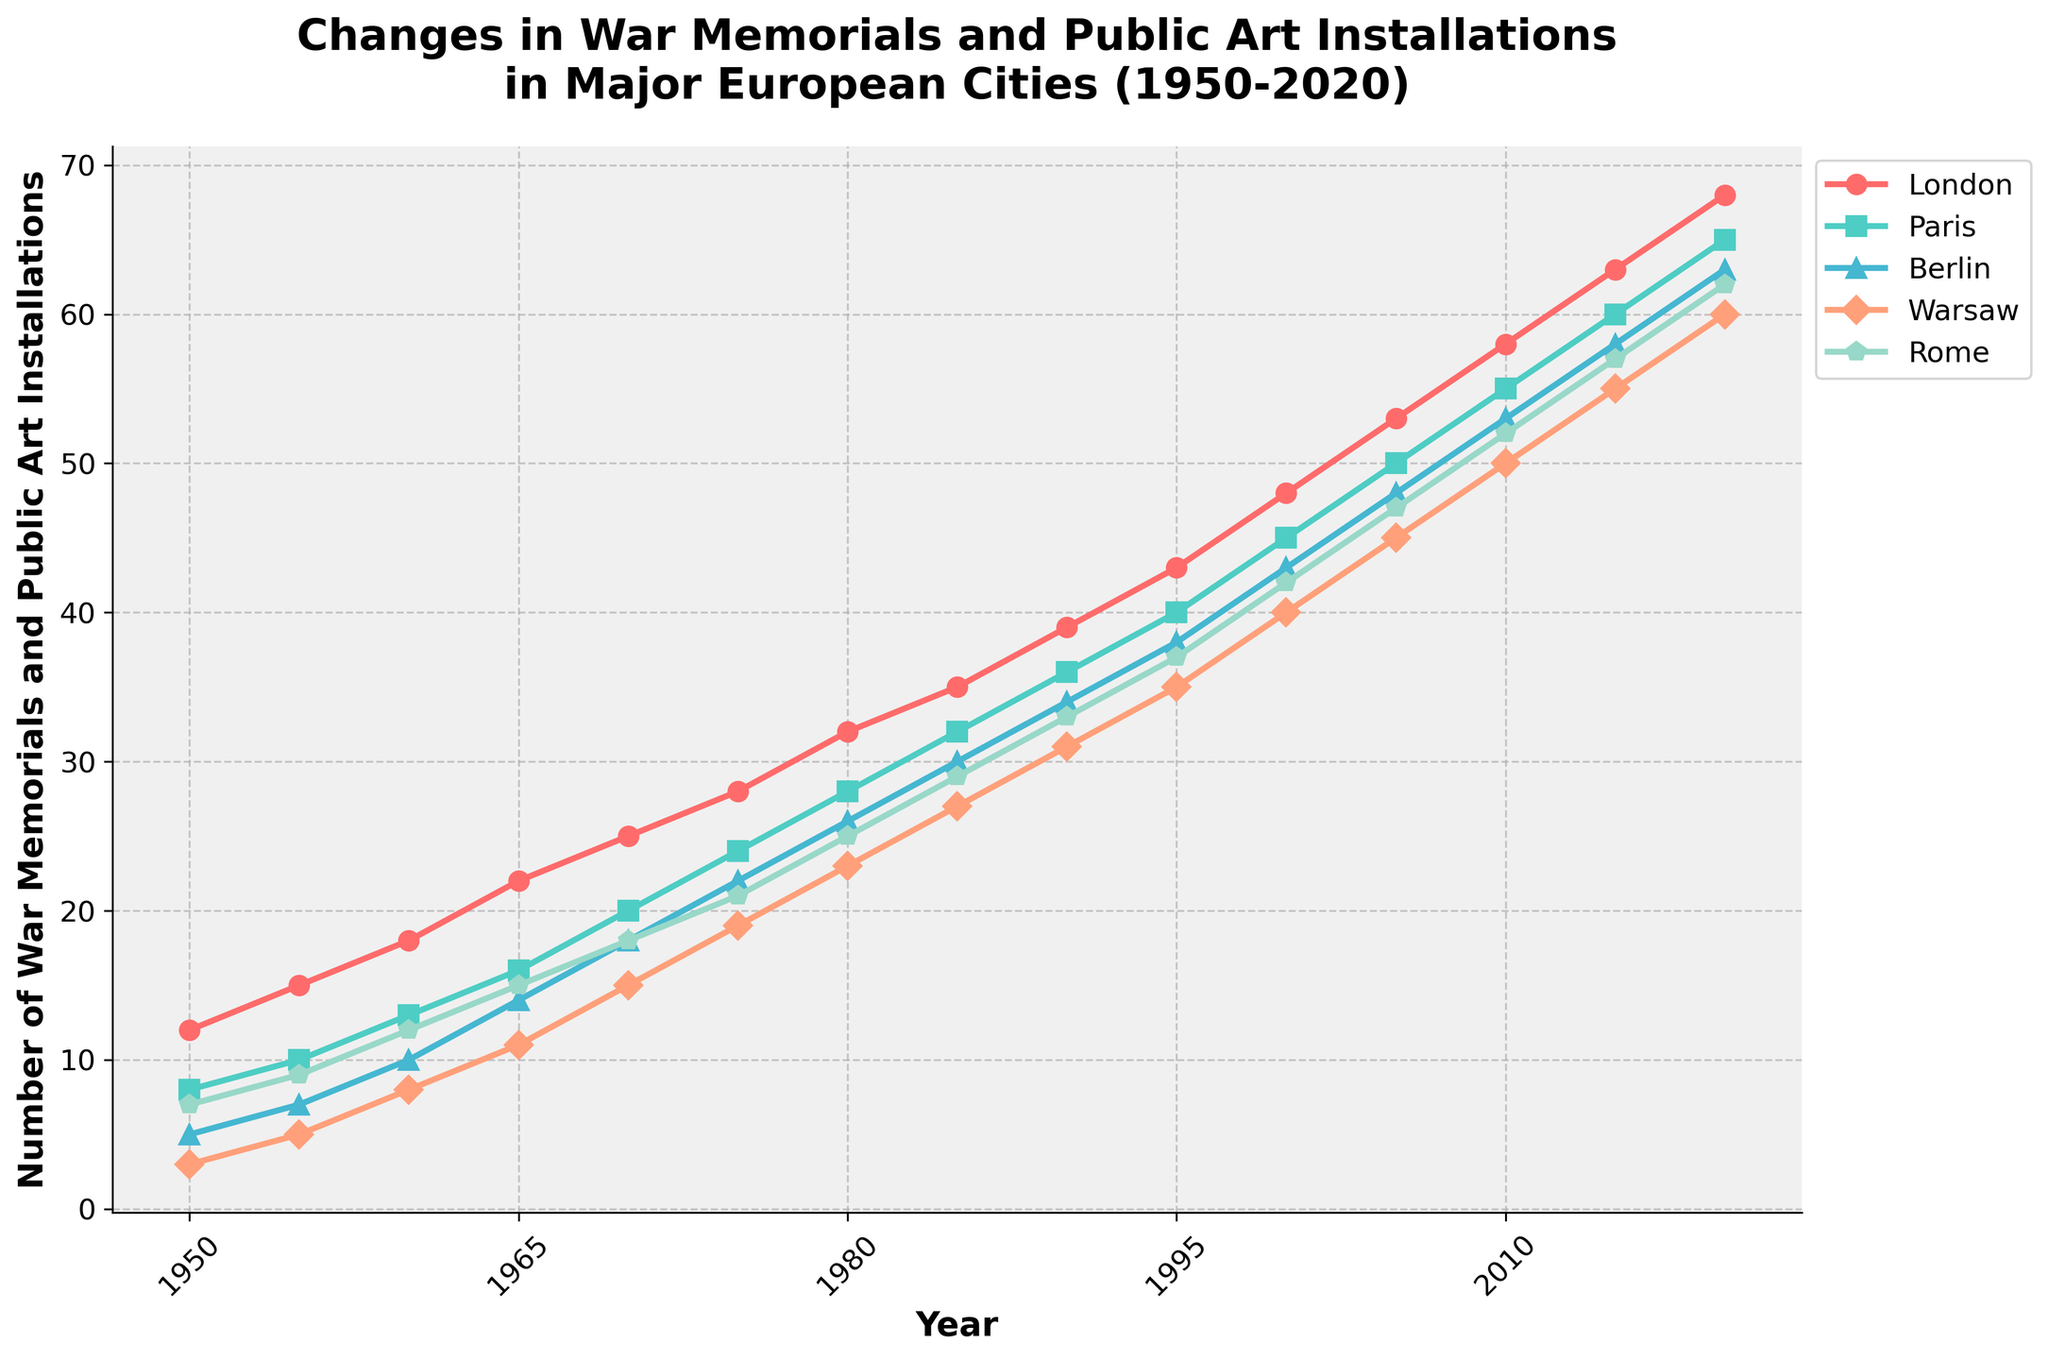What is the overall trend in the number of memorials and installations in London from 1950 to 2020? The line for London shows a consistent upward trend from 1950 (12) to 2020 (68). This indicates a steady increase in the number of memorials and installations over time.
Answer: Consistent upward trend How does the number of memorials and installations in Berlin in 1980 compare to that in Warsaw? In 1980, Berlin has 26 memorials, whereas Warsaw has 23. Comparing these two values, Berlin has 3 more memorials than Warsaw.
Answer: Berlin has 3 more Which city had the highest number of memorials and public art installations in 2000? Looking at the 2000 data points, London has the highest number with 48 memorials and installations.
Answer: London What is the average number of memorials and installations in Rome across all the years shown? To find the average, sum the values for Rome from 1950 to 2020 and divide by the number of years. (7+9+12+15+18+21+25+29+33+37+42+47+52+57+62)/15 = 32.6
Answer: 32.6 What is the difference in the number of memorials and installations between Paris and Warsaw in 2015? In 2015, Paris has 60 memorials while Warsaw has 55. The difference is 60 - 55 = 5.
Answer: 5 Which city had the most rapid growth in the number of memorials and installations between 1950 and 2020? By examining the slopes of the lines, London shows the steepest increase from 12 in 1950 to 68 in 2020, reflecting the most rapid growth.
Answer: London How many more memorials and installations were there in London in 2020 compared to 1950? In 2020, London had 68 memorials, and in 1950, it had 12. The difference is 68 - 12 = 56.
Answer: 56 What is the total number of memorials and installations across all cities in 1990? Summing the values for each city in 1990: 39 (London) + 36 (Paris) + 34 (Berlin) + 31 (Warsaw) + 33 (Rome) = 173.
Answer: 173 Which city has the second-highest number of memorials and installations in 1975? In 1975, Paris has 24, which is the second-highest after London (28).
Answer: Paris What year did Warsaw surpass 40 memorials and installations for the first time? Warsaw surpasses 40 memorials in 2000, where it has 40, and in 2005 it records 45, marking the first surpassing year at 2005.
Answer: 2005 